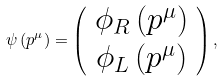<formula> <loc_0><loc_0><loc_500><loc_500>\psi \left ( p ^ { \mu } \right ) = \left ( \begin{array} { c } \phi _ { R } \left ( p ^ { \mu } \right ) \\ \phi _ { L } \left ( p ^ { \mu } \right ) \end{array} \right ) ,</formula> 